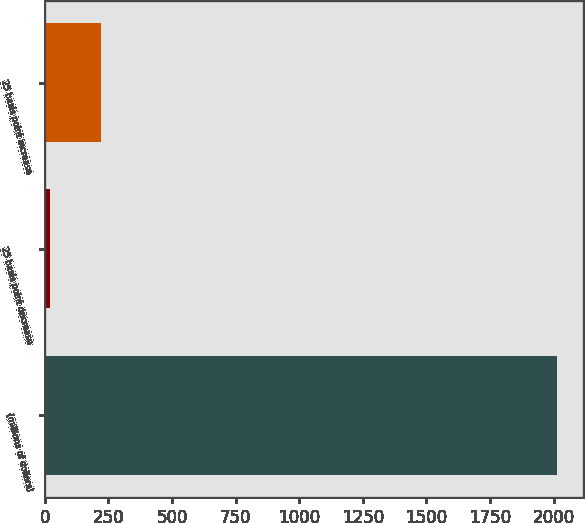Convert chart to OTSL. <chart><loc_0><loc_0><loc_500><loc_500><bar_chart><fcel>(millions of dollars)<fcel>25 basis point decrease<fcel>25 basis point increase<nl><fcel>2014<fcel>20.8<fcel>220.12<nl></chart> 